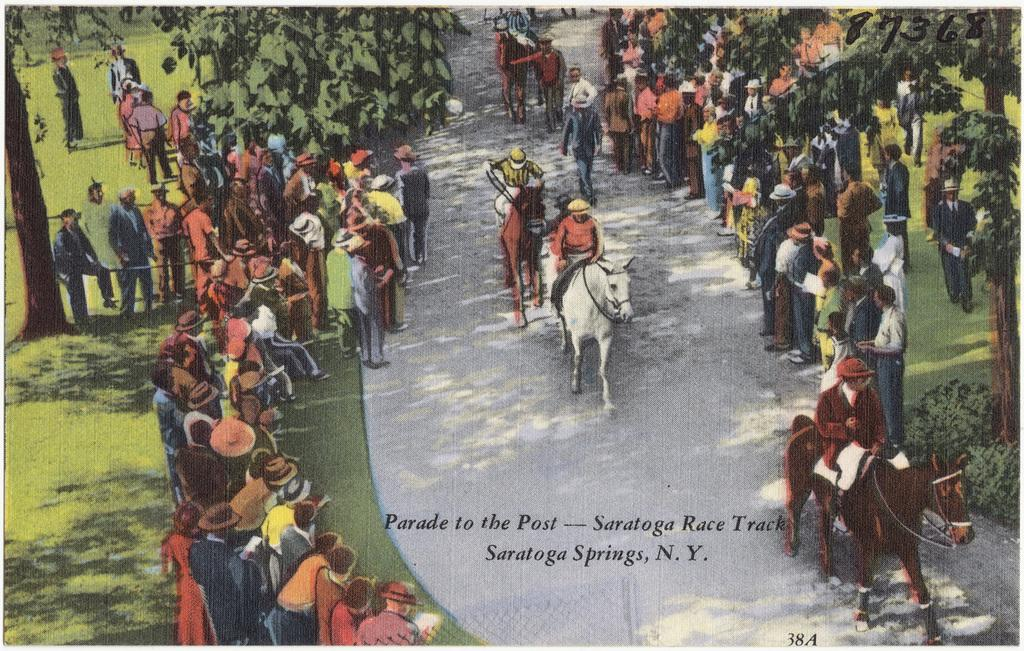What are the people in the image doing? There are people standing and riding horses in the image. What can be seen in the background of the image? Trees are visible in the image. What accessories are some people wearing in the image? Some people are wearing hats in the image. What is present at the bottom of the image? There is text at the bottom of the image. What type of mint is being used to decorate the horses in the image? There is no mint present in the image, and the horses are not being decorated with mint. 